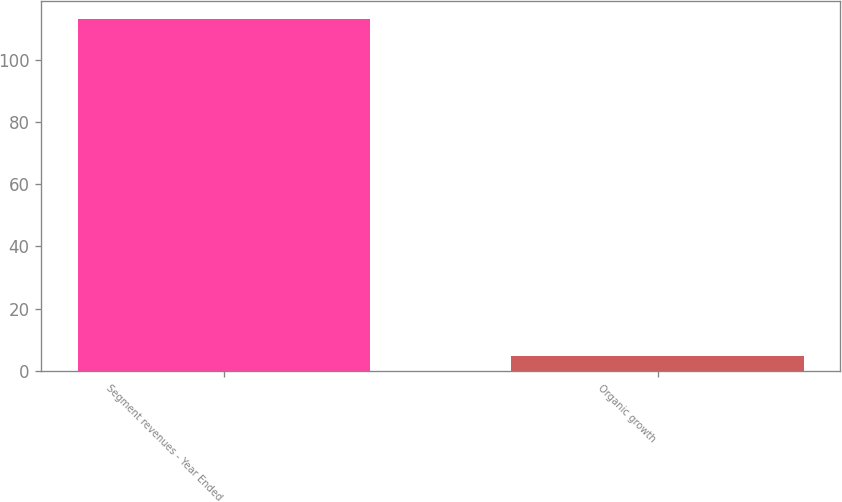Convert chart to OTSL. <chart><loc_0><loc_0><loc_500><loc_500><bar_chart><fcel>Segment revenues - Year Ended<fcel>Organic growth<nl><fcel>113.2<fcel>4.8<nl></chart> 